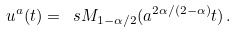<formula> <loc_0><loc_0><loc_500><loc_500>u ^ { a } ( t ) = \ s M _ { 1 - \alpha / 2 } ( a ^ { 2 \alpha / ( 2 - \alpha ) } t ) \, .</formula> 